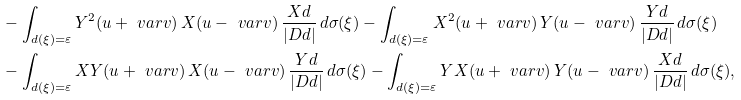<formula> <loc_0><loc_0><loc_500><loc_500>& - \int _ { d ( \xi ) = \varepsilon } Y ^ { 2 } ( u + \ v a r v ) \, X ( u - \ v a r v ) \, \frac { X d } { | D d | } \, d \sigma ( \xi ) - \int _ { d ( \xi ) = \varepsilon } X ^ { 2 } ( u + \ v a r v ) \, Y ( u - \ v a r v ) \, \frac { Y d } { | D d | } \, d \sigma ( \xi ) \\ & - \int _ { d ( \xi ) = \varepsilon } X Y ( u + \ v a r v ) \, X ( u - \ v a r v ) \, \frac { Y d } { | D d | } \, d \sigma ( \xi ) - \int _ { d ( \xi ) = \varepsilon } Y X ( u + \ v a r v ) \, Y ( u - \ v a r v ) \, \frac { X d } { | D d | } \, d \sigma ( \xi ) ,</formula> 